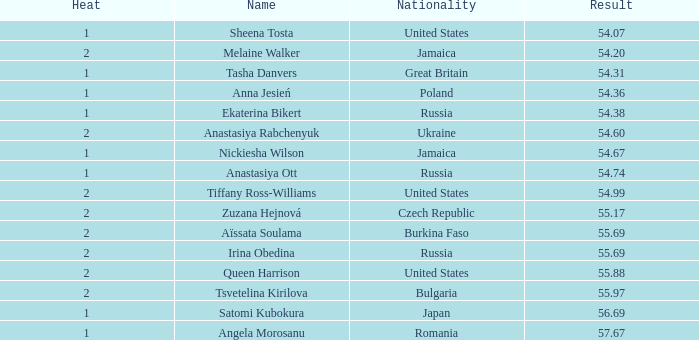Which heat possesses a nationality of bulgaria and a result exceeding 5 None. 